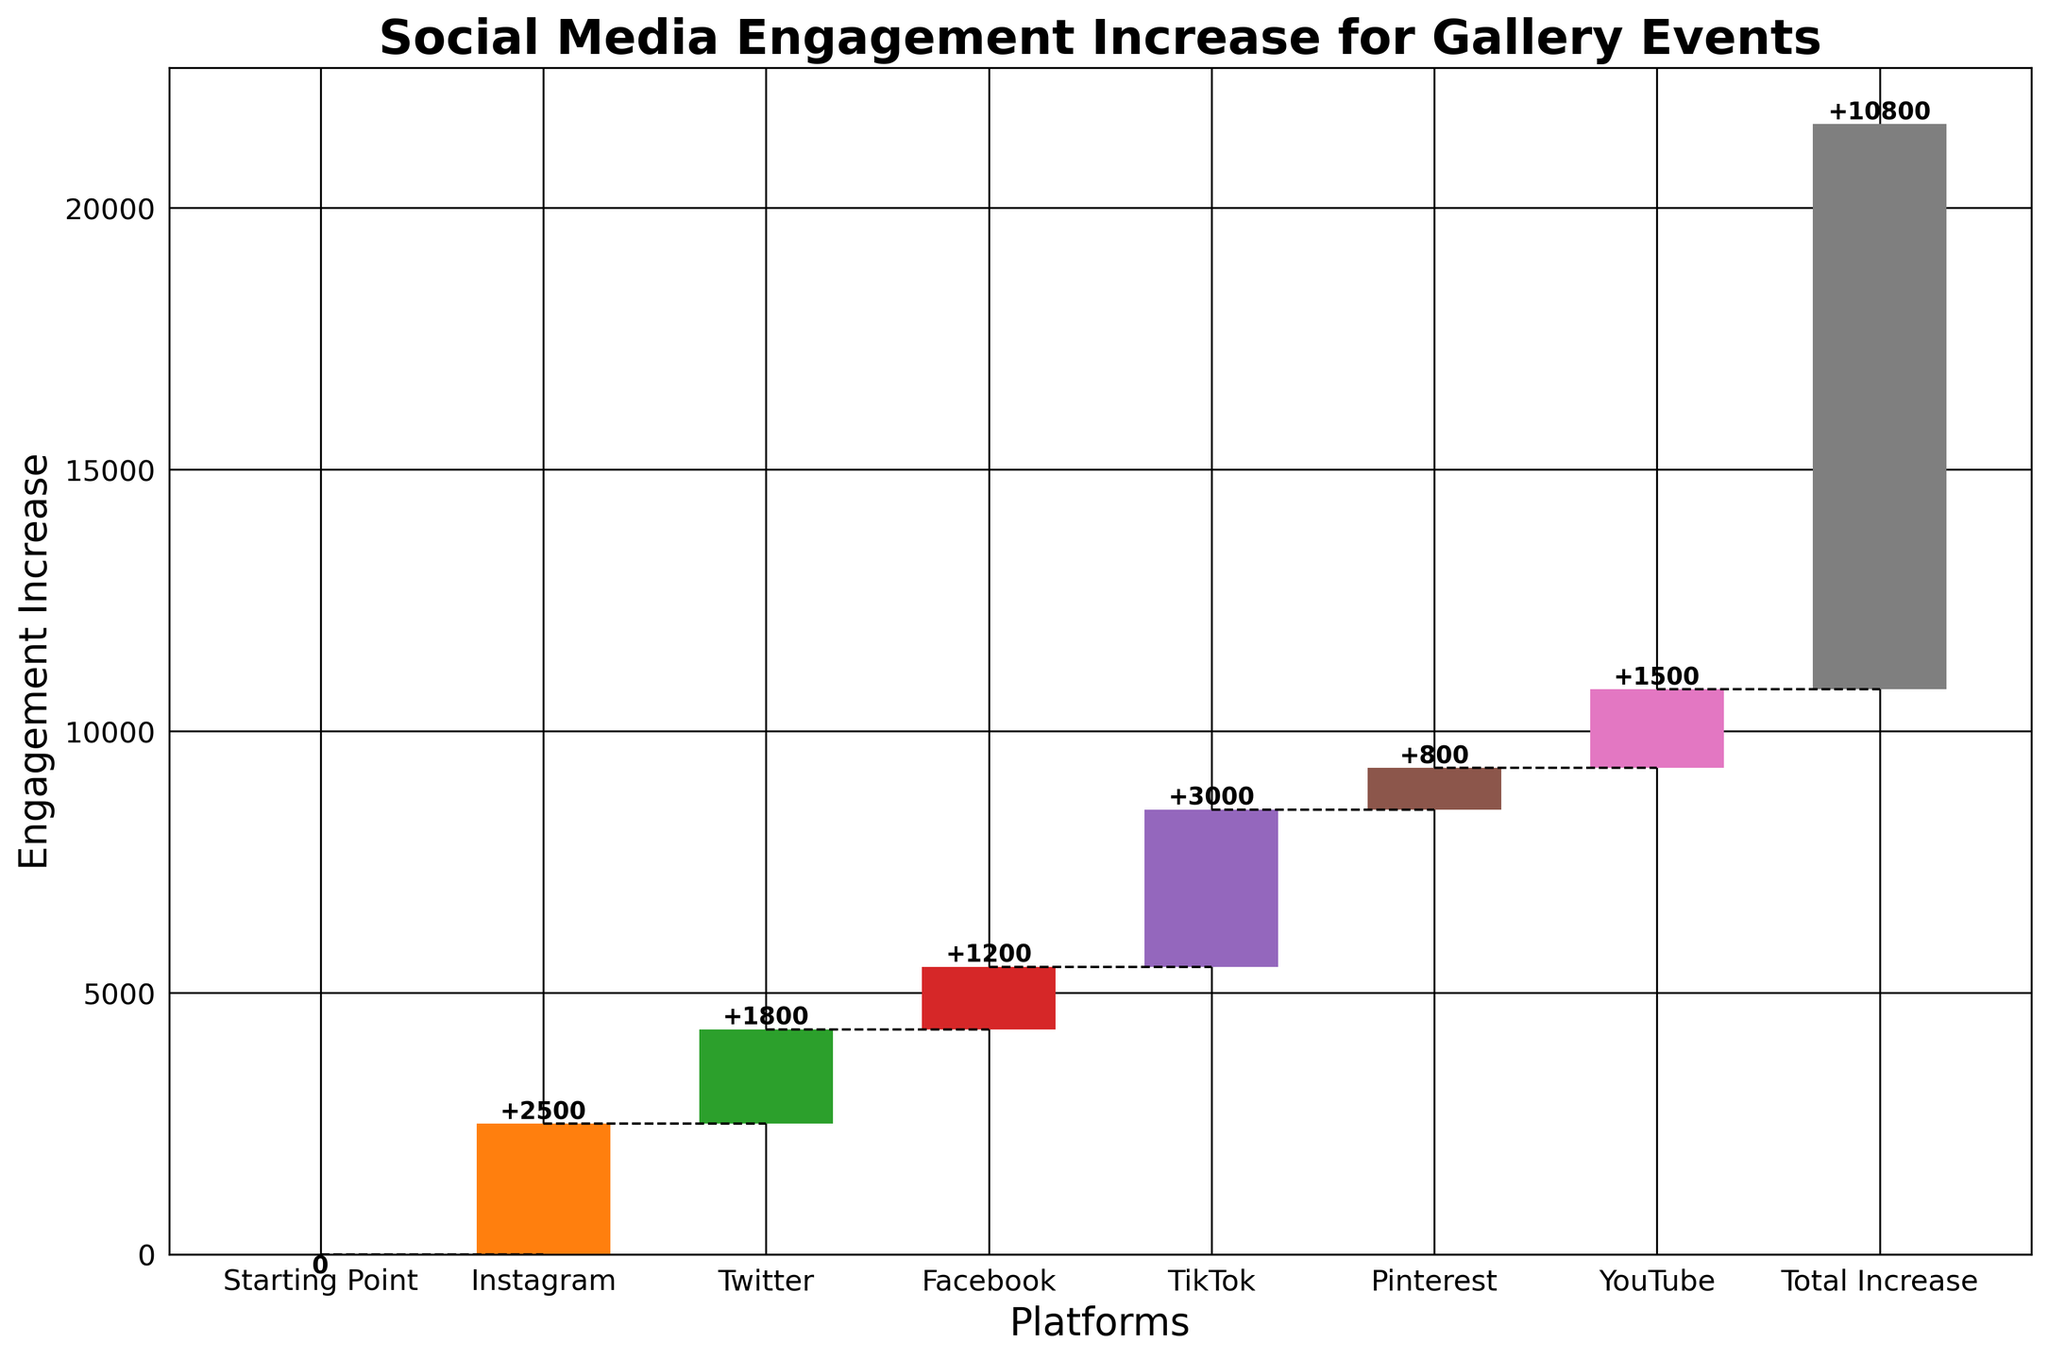What is the title of the figure? The title is always shown at the top of the plot. Looking at the top, we can read the exact text used.
Answer: Social Media Engagement Increase for Gallery Events What is the engagement increase for Instagram? Read the bar label associated with Instagram. The value is shown on top of the bar.
Answer: 2500 Which platform has the highest engagement increase displayed? Compare the height of all the bars. The highest bar corresponds to the maximum increase in engagement.
Answer: TikTok How much higher is TikTok's engagement increase compared to Twitter's? Locate the bars for TikTok and Twitter, then subtract Twitter's value from TikTok’s value.
Answer: 1200 What is the cumulative engagement increase at the end of the chart? The last value at the end of the chart represents the total of all previous increases.
Answer: 10800 Between which platforms do we see the least engagement increase? Compare the heights of all bars and identify the smallest one.
Answer: Pinterest What is the combined engagement increase for Facebook and YouTube? Add Facebook’s value to YouTube’s value.
Answer: 2700 In which order are the platforms listed from left to right based on the chart? Read the names of the platforms in order from the leftmost bar to the rightmost bar.
Answer: Starting Point, Instagram, Twitter, Facebook, TikTok, Pinterest, YouTube, Total Increase How many platforms showed an increase in engagement? Count the number of bars excluding 'Starting Point' and 'Total Increase'.
Answer: 6 What is the average engagement increase across all platforms excluding the starting point? Sum the engagement increases for all platforms excluding the starting point, then divide by the number of those platforms.
Answer: 1800 